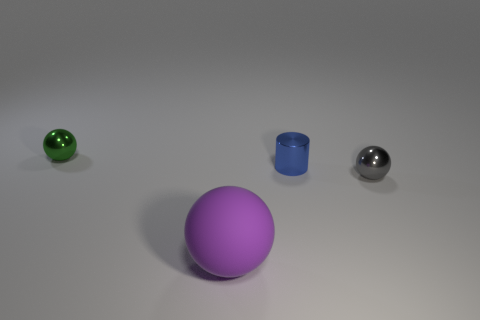Is there any other thing that is the same size as the purple thing?
Give a very brief answer. No. Does the metallic cylinder have the same color as the large rubber sphere?
Offer a very short reply. No. Is the number of gray metallic things in front of the purple sphere less than the number of small gray metallic balls left of the small gray thing?
Your answer should be very brief. No. Do the small blue cylinder and the green thing have the same material?
Ensure brevity in your answer.  Yes. There is a object that is to the right of the big purple matte thing and in front of the tiny blue object; how big is it?
Your answer should be very brief. Small. What shape is the blue shiny object that is the same size as the gray shiny object?
Your answer should be compact. Cylinder. The purple sphere in front of the small gray metallic sphere that is in front of the tiny metallic ball that is left of the matte object is made of what material?
Offer a terse response. Rubber. Is the shape of the tiny thing on the left side of the large purple rubber object the same as the blue thing on the right side of the purple object?
Ensure brevity in your answer.  No. How many other things are there of the same material as the big purple ball?
Offer a very short reply. 0. Is the small sphere behind the gray metallic sphere made of the same material as the object that is in front of the gray ball?
Ensure brevity in your answer.  No. 